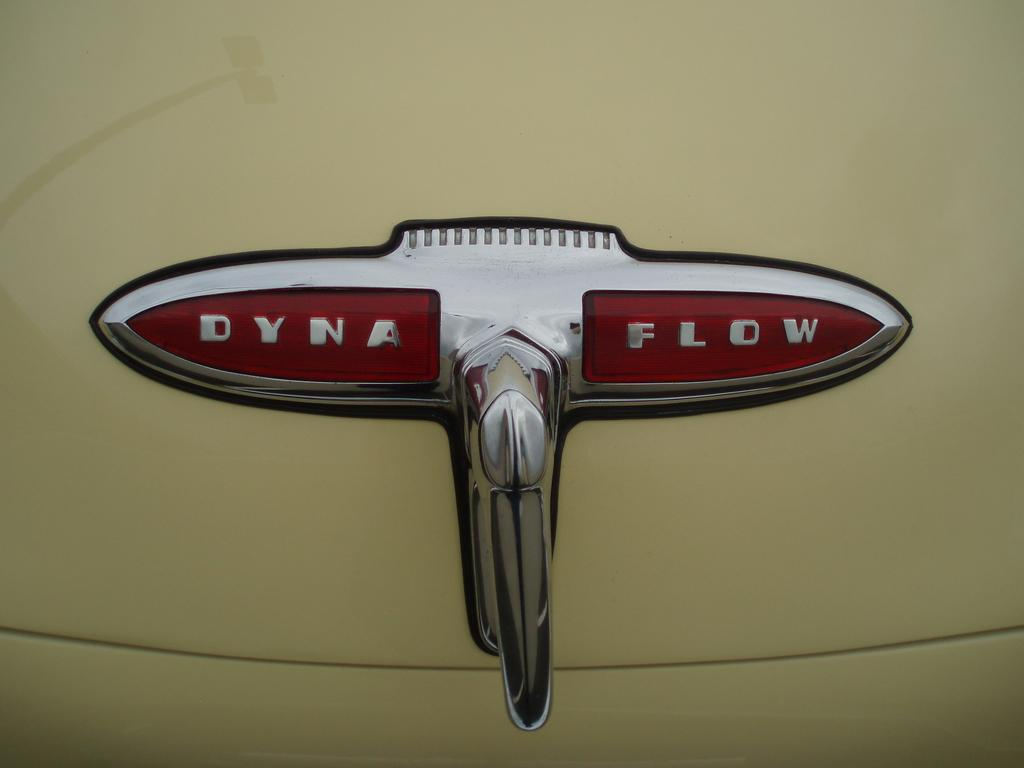What is the main subject of the image? There is an object in the image. What is the color of the surface on which the object is placed? The object is on a white-colored surface. What can be seen on the object itself? There is text on the object. Is there a baby lawyer using the sink in the image? There is no baby lawyer or sink present in the image. 